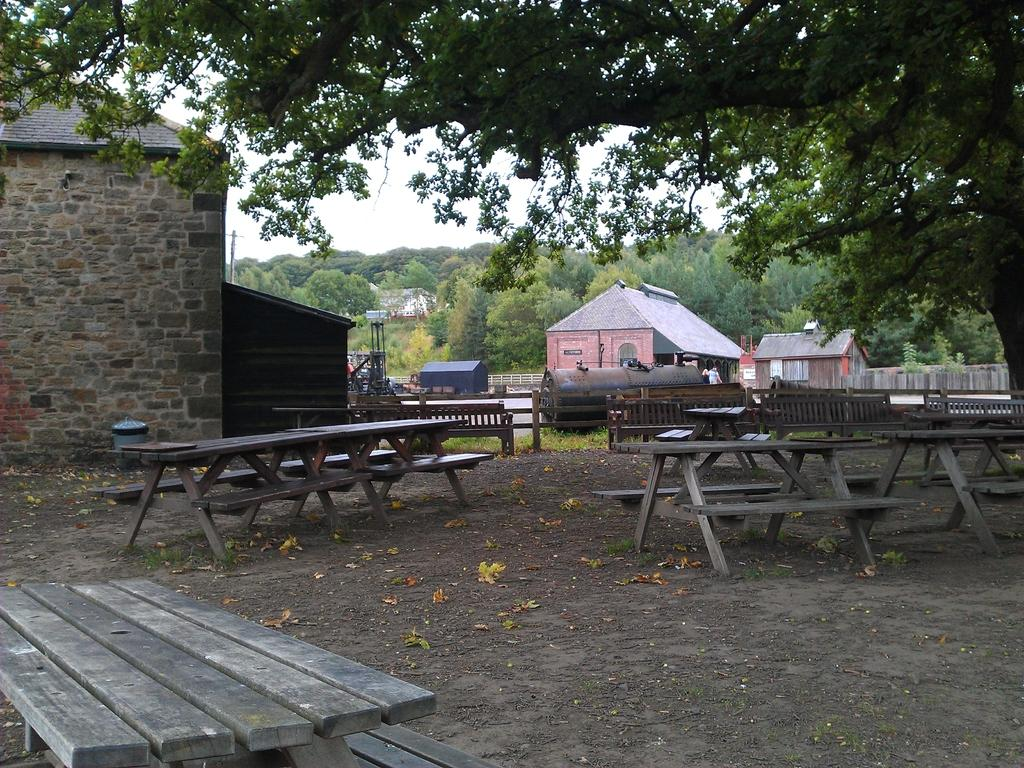What type of furniture is visible in the image? There are wooden tables and chairs in the image. What can be seen in the distance behind the furniture? There are houses, trees, and a man in the background of the image. What is the nature of the boundary visible in the background? There is a boundary in the background of the image, but its specific nature is not clear from the facts provided. What type of dinner is being served at the cemetery in the image? There is no cemetery or dinner present in the image; it features wooden tables and chairs with a background of houses, trees, and a man. 